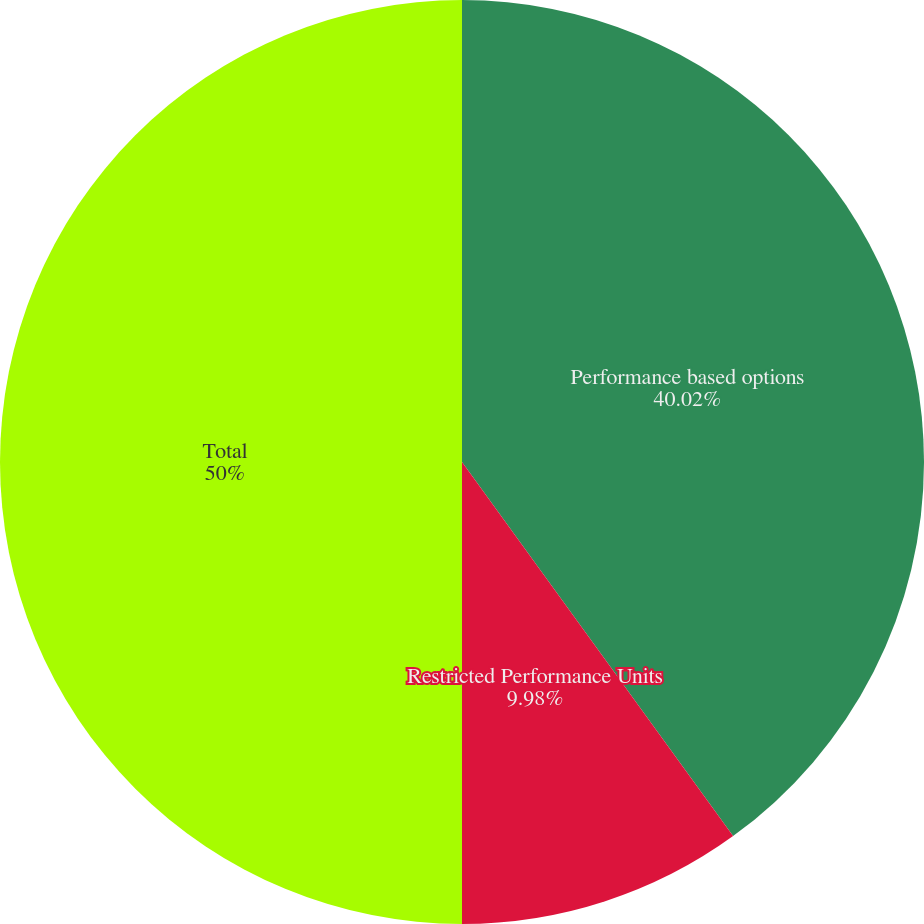Convert chart. <chart><loc_0><loc_0><loc_500><loc_500><pie_chart><fcel>Performance based options<fcel>Restricted Performance Units<fcel>Total<nl><fcel>40.02%<fcel>9.98%<fcel>50.0%<nl></chart> 